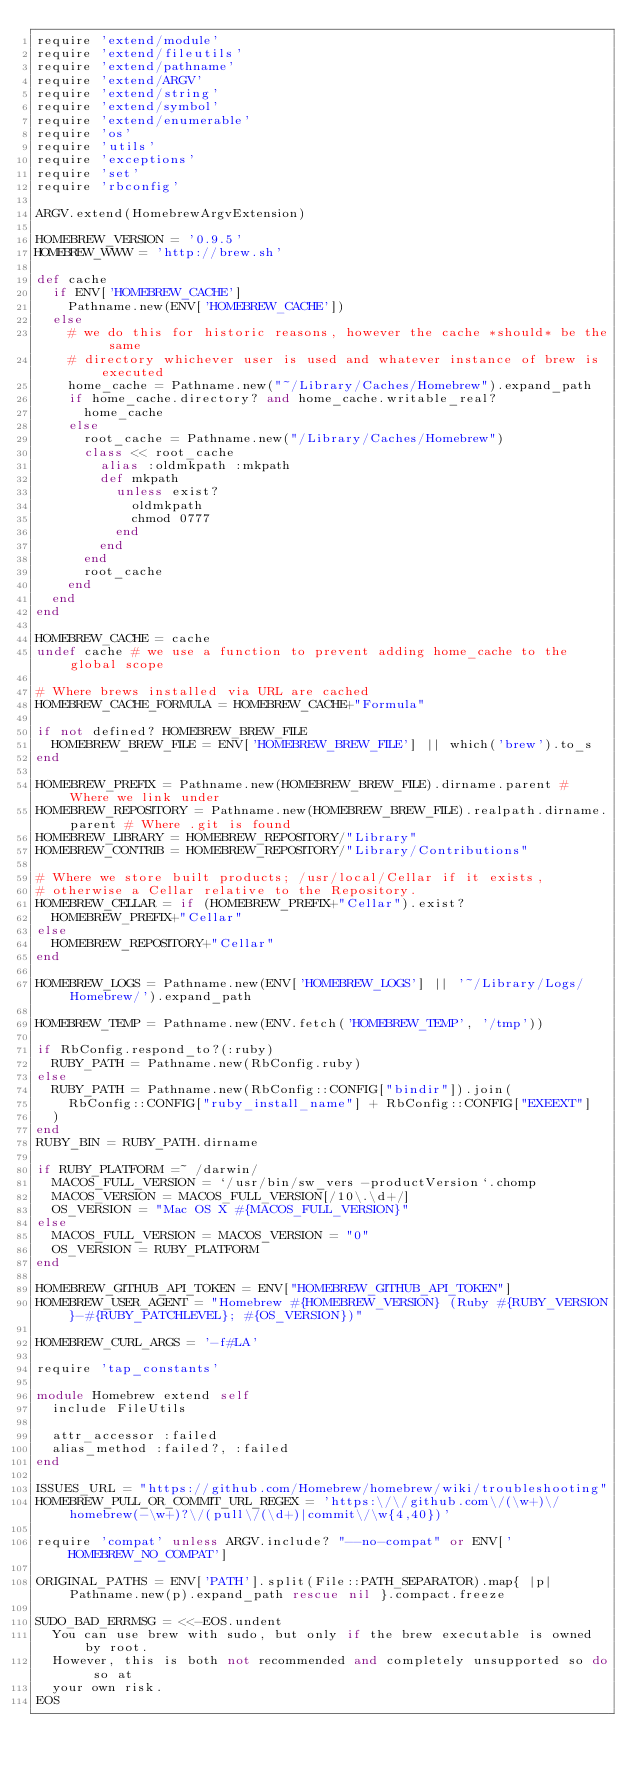<code> <loc_0><loc_0><loc_500><loc_500><_Ruby_>require 'extend/module'
require 'extend/fileutils'
require 'extend/pathname'
require 'extend/ARGV'
require 'extend/string'
require 'extend/symbol'
require 'extend/enumerable'
require 'os'
require 'utils'
require 'exceptions'
require 'set'
require 'rbconfig'

ARGV.extend(HomebrewArgvExtension)

HOMEBREW_VERSION = '0.9.5'
HOMEBREW_WWW = 'http://brew.sh'

def cache
  if ENV['HOMEBREW_CACHE']
    Pathname.new(ENV['HOMEBREW_CACHE'])
  else
    # we do this for historic reasons, however the cache *should* be the same
    # directory whichever user is used and whatever instance of brew is executed
    home_cache = Pathname.new("~/Library/Caches/Homebrew").expand_path
    if home_cache.directory? and home_cache.writable_real?
      home_cache
    else
      root_cache = Pathname.new("/Library/Caches/Homebrew")
      class << root_cache
        alias :oldmkpath :mkpath
        def mkpath
          unless exist?
            oldmkpath
            chmod 0777
          end
        end
      end
      root_cache
    end
  end
end

HOMEBREW_CACHE = cache
undef cache # we use a function to prevent adding home_cache to the global scope

# Where brews installed via URL are cached
HOMEBREW_CACHE_FORMULA = HOMEBREW_CACHE+"Formula"

if not defined? HOMEBREW_BREW_FILE
  HOMEBREW_BREW_FILE = ENV['HOMEBREW_BREW_FILE'] || which('brew').to_s
end

HOMEBREW_PREFIX = Pathname.new(HOMEBREW_BREW_FILE).dirname.parent # Where we link under
HOMEBREW_REPOSITORY = Pathname.new(HOMEBREW_BREW_FILE).realpath.dirname.parent # Where .git is found
HOMEBREW_LIBRARY = HOMEBREW_REPOSITORY/"Library"
HOMEBREW_CONTRIB = HOMEBREW_REPOSITORY/"Library/Contributions"

# Where we store built products; /usr/local/Cellar if it exists,
# otherwise a Cellar relative to the Repository.
HOMEBREW_CELLAR = if (HOMEBREW_PREFIX+"Cellar").exist?
  HOMEBREW_PREFIX+"Cellar"
else
  HOMEBREW_REPOSITORY+"Cellar"
end

HOMEBREW_LOGS = Pathname.new(ENV['HOMEBREW_LOGS'] || '~/Library/Logs/Homebrew/').expand_path

HOMEBREW_TEMP = Pathname.new(ENV.fetch('HOMEBREW_TEMP', '/tmp'))

if RbConfig.respond_to?(:ruby)
  RUBY_PATH = Pathname.new(RbConfig.ruby)
else
  RUBY_PATH = Pathname.new(RbConfig::CONFIG["bindir"]).join(
    RbConfig::CONFIG["ruby_install_name"] + RbConfig::CONFIG["EXEEXT"]
  )
end
RUBY_BIN = RUBY_PATH.dirname

if RUBY_PLATFORM =~ /darwin/
  MACOS_FULL_VERSION = `/usr/bin/sw_vers -productVersion`.chomp
  MACOS_VERSION = MACOS_FULL_VERSION[/10\.\d+/]
  OS_VERSION = "Mac OS X #{MACOS_FULL_VERSION}"
else
  MACOS_FULL_VERSION = MACOS_VERSION = "0"
  OS_VERSION = RUBY_PLATFORM
end

HOMEBREW_GITHUB_API_TOKEN = ENV["HOMEBREW_GITHUB_API_TOKEN"]
HOMEBREW_USER_AGENT = "Homebrew #{HOMEBREW_VERSION} (Ruby #{RUBY_VERSION}-#{RUBY_PATCHLEVEL}; #{OS_VERSION})"

HOMEBREW_CURL_ARGS = '-f#LA'

require 'tap_constants'

module Homebrew extend self
  include FileUtils

  attr_accessor :failed
  alias_method :failed?, :failed
end

ISSUES_URL = "https://github.com/Homebrew/homebrew/wiki/troubleshooting"
HOMEBREW_PULL_OR_COMMIT_URL_REGEX = 'https:\/\/github.com\/(\w+)\/homebrew(-\w+)?\/(pull\/(\d+)|commit\/\w{4,40})'

require 'compat' unless ARGV.include? "--no-compat" or ENV['HOMEBREW_NO_COMPAT']

ORIGINAL_PATHS = ENV['PATH'].split(File::PATH_SEPARATOR).map{ |p| Pathname.new(p).expand_path rescue nil }.compact.freeze

SUDO_BAD_ERRMSG = <<-EOS.undent
  You can use brew with sudo, but only if the brew executable is owned by root.
  However, this is both not recommended and completely unsupported so do so at
  your own risk.
EOS
</code> 